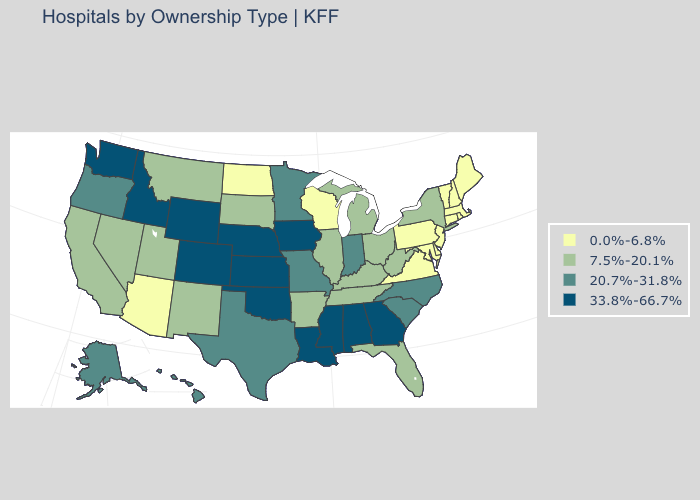Name the states that have a value in the range 0.0%-6.8%?
Be succinct. Arizona, Connecticut, Delaware, Maine, Maryland, Massachusetts, New Hampshire, New Jersey, North Dakota, Pennsylvania, Rhode Island, Vermont, Virginia, Wisconsin. What is the value of Georgia?
Give a very brief answer. 33.8%-66.7%. What is the value of Kansas?
Be succinct. 33.8%-66.7%. Which states have the highest value in the USA?
Concise answer only. Alabama, Colorado, Georgia, Idaho, Iowa, Kansas, Louisiana, Mississippi, Nebraska, Oklahoma, Washington, Wyoming. What is the highest value in the USA?
Give a very brief answer. 33.8%-66.7%. Which states have the lowest value in the USA?
Give a very brief answer. Arizona, Connecticut, Delaware, Maine, Maryland, Massachusetts, New Hampshire, New Jersey, North Dakota, Pennsylvania, Rhode Island, Vermont, Virginia, Wisconsin. Which states hav the highest value in the West?
Quick response, please. Colorado, Idaho, Washington, Wyoming. Name the states that have a value in the range 20.7%-31.8%?
Answer briefly. Alaska, Hawaii, Indiana, Minnesota, Missouri, North Carolina, Oregon, South Carolina, Texas. Does the first symbol in the legend represent the smallest category?
Give a very brief answer. Yes. What is the value of Minnesota?
Quick response, please. 20.7%-31.8%. Name the states that have a value in the range 7.5%-20.1%?
Quick response, please. Arkansas, California, Florida, Illinois, Kentucky, Michigan, Montana, Nevada, New Mexico, New York, Ohio, South Dakota, Tennessee, Utah, West Virginia. What is the value of Washington?
Short answer required. 33.8%-66.7%. What is the value of Oregon?
Give a very brief answer. 20.7%-31.8%. What is the value of Maryland?
Write a very short answer. 0.0%-6.8%. 